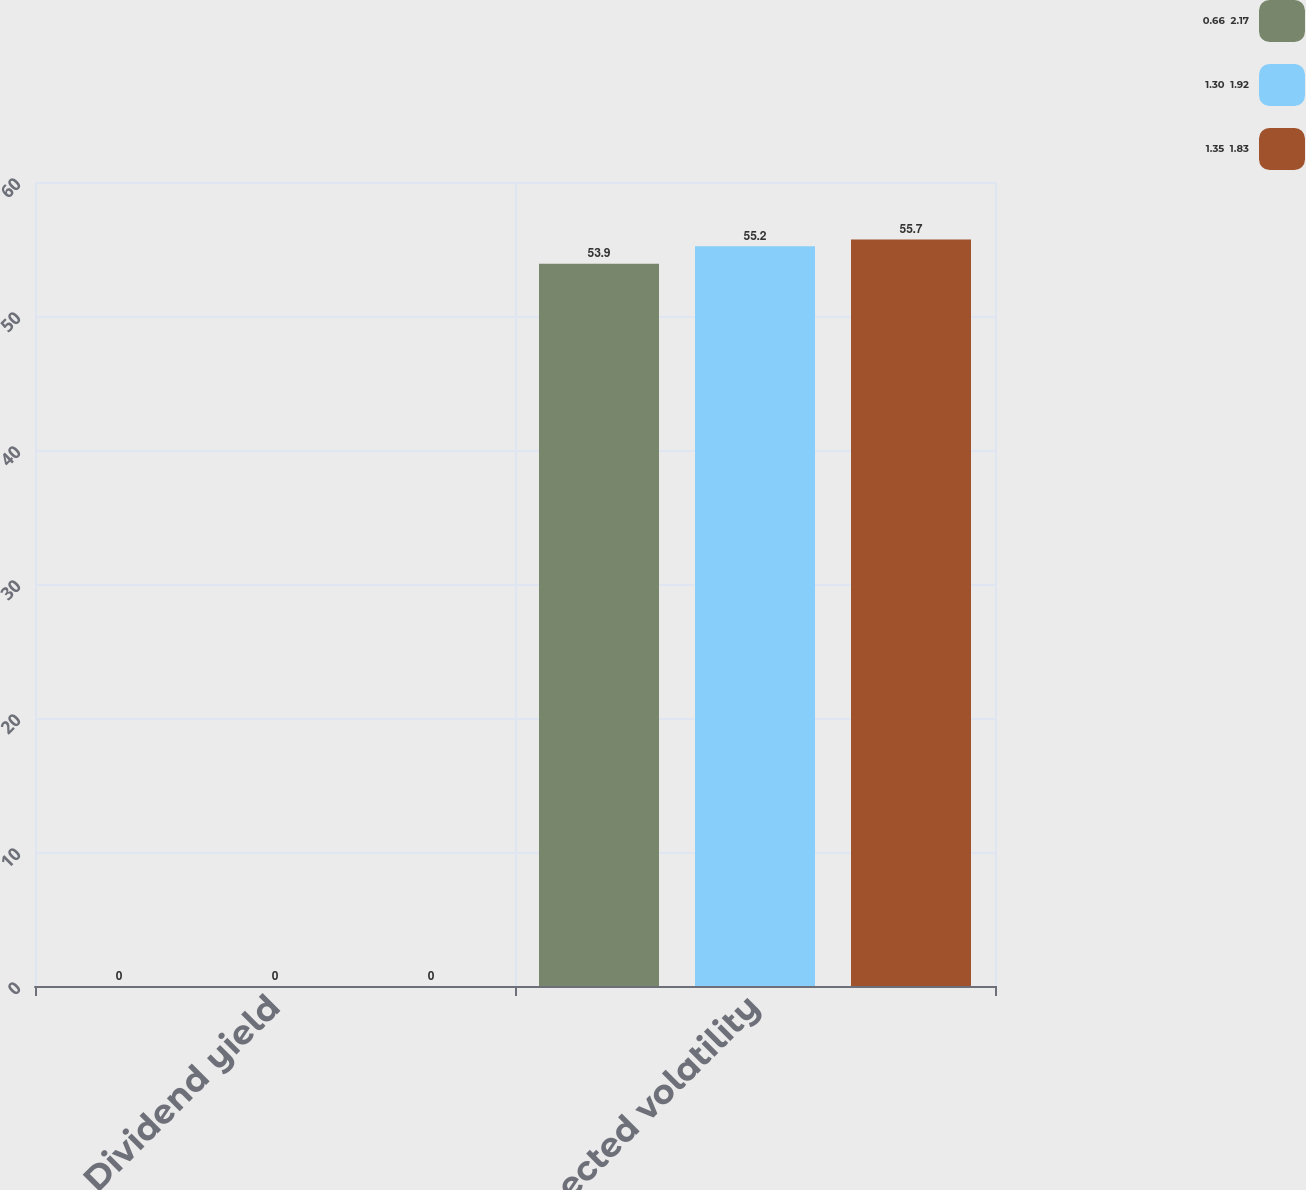Convert chart to OTSL. <chart><loc_0><loc_0><loc_500><loc_500><stacked_bar_chart><ecel><fcel>Dividend yield<fcel>Expected volatility<nl><fcel>0.66  2.17<fcel>0<fcel>53.9<nl><fcel>1.30  1.92<fcel>0<fcel>55.2<nl><fcel>1.35  1.83<fcel>0<fcel>55.7<nl></chart> 